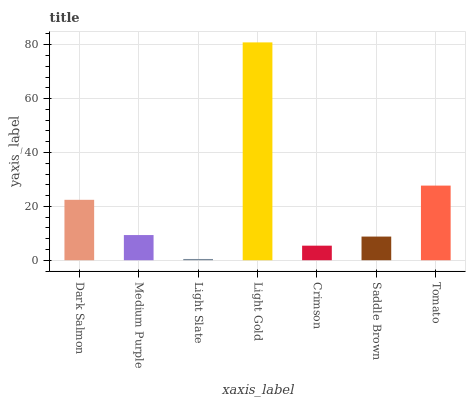Is Light Slate the minimum?
Answer yes or no. Yes. Is Light Gold the maximum?
Answer yes or no. Yes. Is Medium Purple the minimum?
Answer yes or no. No. Is Medium Purple the maximum?
Answer yes or no. No. Is Dark Salmon greater than Medium Purple?
Answer yes or no. Yes. Is Medium Purple less than Dark Salmon?
Answer yes or no. Yes. Is Medium Purple greater than Dark Salmon?
Answer yes or no. No. Is Dark Salmon less than Medium Purple?
Answer yes or no. No. Is Medium Purple the high median?
Answer yes or no. Yes. Is Medium Purple the low median?
Answer yes or no. Yes. Is Dark Salmon the high median?
Answer yes or no. No. Is Saddle Brown the low median?
Answer yes or no. No. 